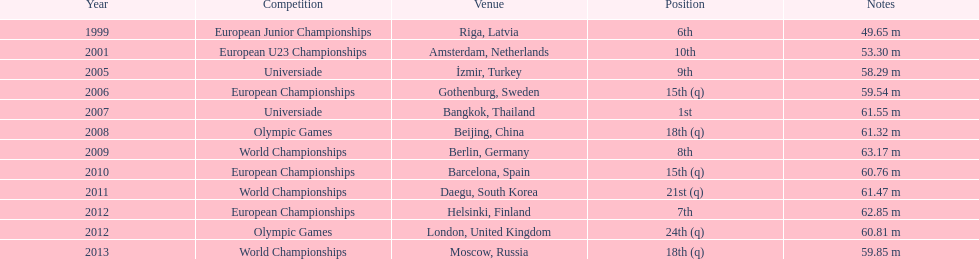Prior to 2007, what was the highest place achieved? 6th. 